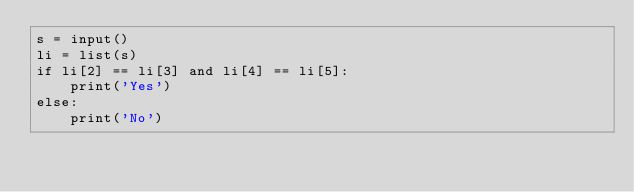Convert code to text. <code><loc_0><loc_0><loc_500><loc_500><_Python_>s = input()
li = list(s)
if li[2] == li[3] and li[4] == li[5]:
    print('Yes')
else:
    print('No')
</code> 